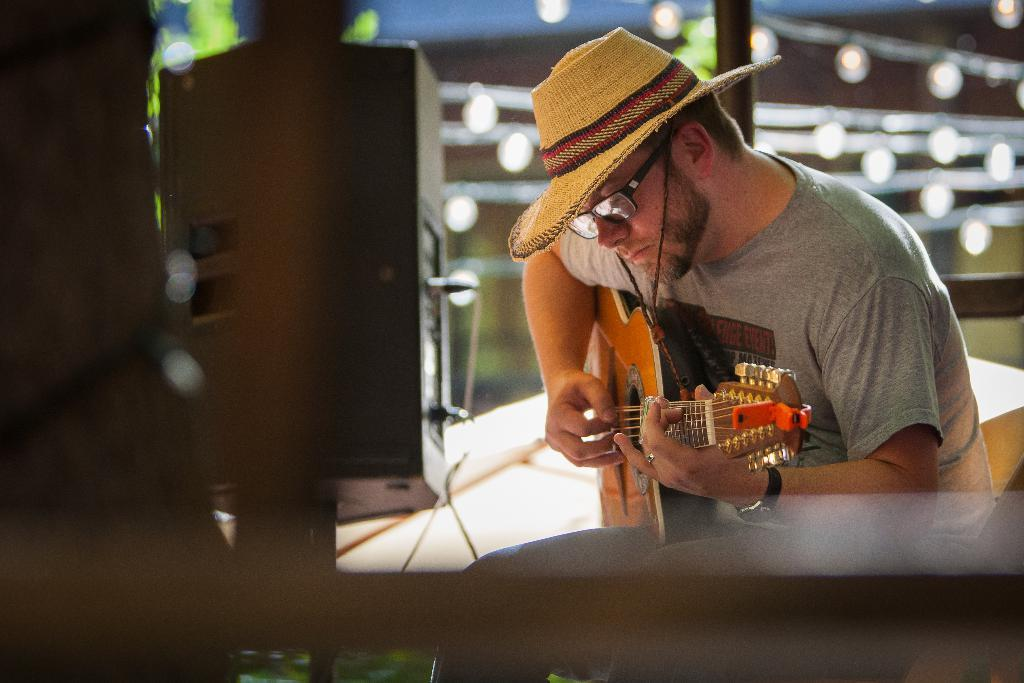Who is the main subject in the image? There is a person in the image. What is the person doing in the image? The person is playing a guitar. Can you describe the person's attire in the image? The person is wearing a cap. What object is located on the left side of the image? There is a speaker on the left side of the image. What caused the person to take flight in the image? There is no indication in the image that the person took flight or that any cause for flight is present. 